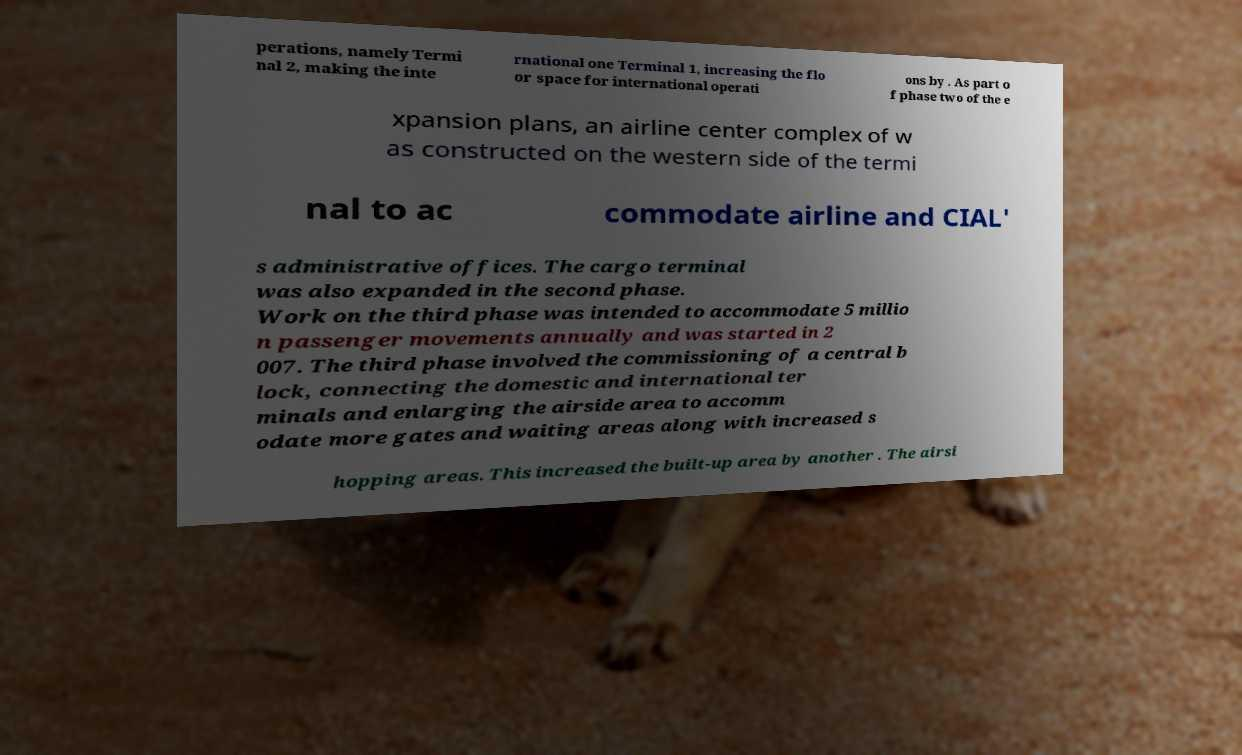Could you extract and type out the text from this image? perations, namely Termi nal 2, making the inte rnational one Terminal 1, increasing the flo or space for international operati ons by . As part o f phase two of the e xpansion plans, an airline center complex of w as constructed on the western side of the termi nal to ac commodate airline and CIAL' s administrative offices. The cargo terminal was also expanded in the second phase. Work on the third phase was intended to accommodate 5 millio n passenger movements annually and was started in 2 007. The third phase involved the commissioning of a central b lock, connecting the domestic and international ter minals and enlarging the airside area to accomm odate more gates and waiting areas along with increased s hopping areas. This increased the built-up area by another . The airsi 